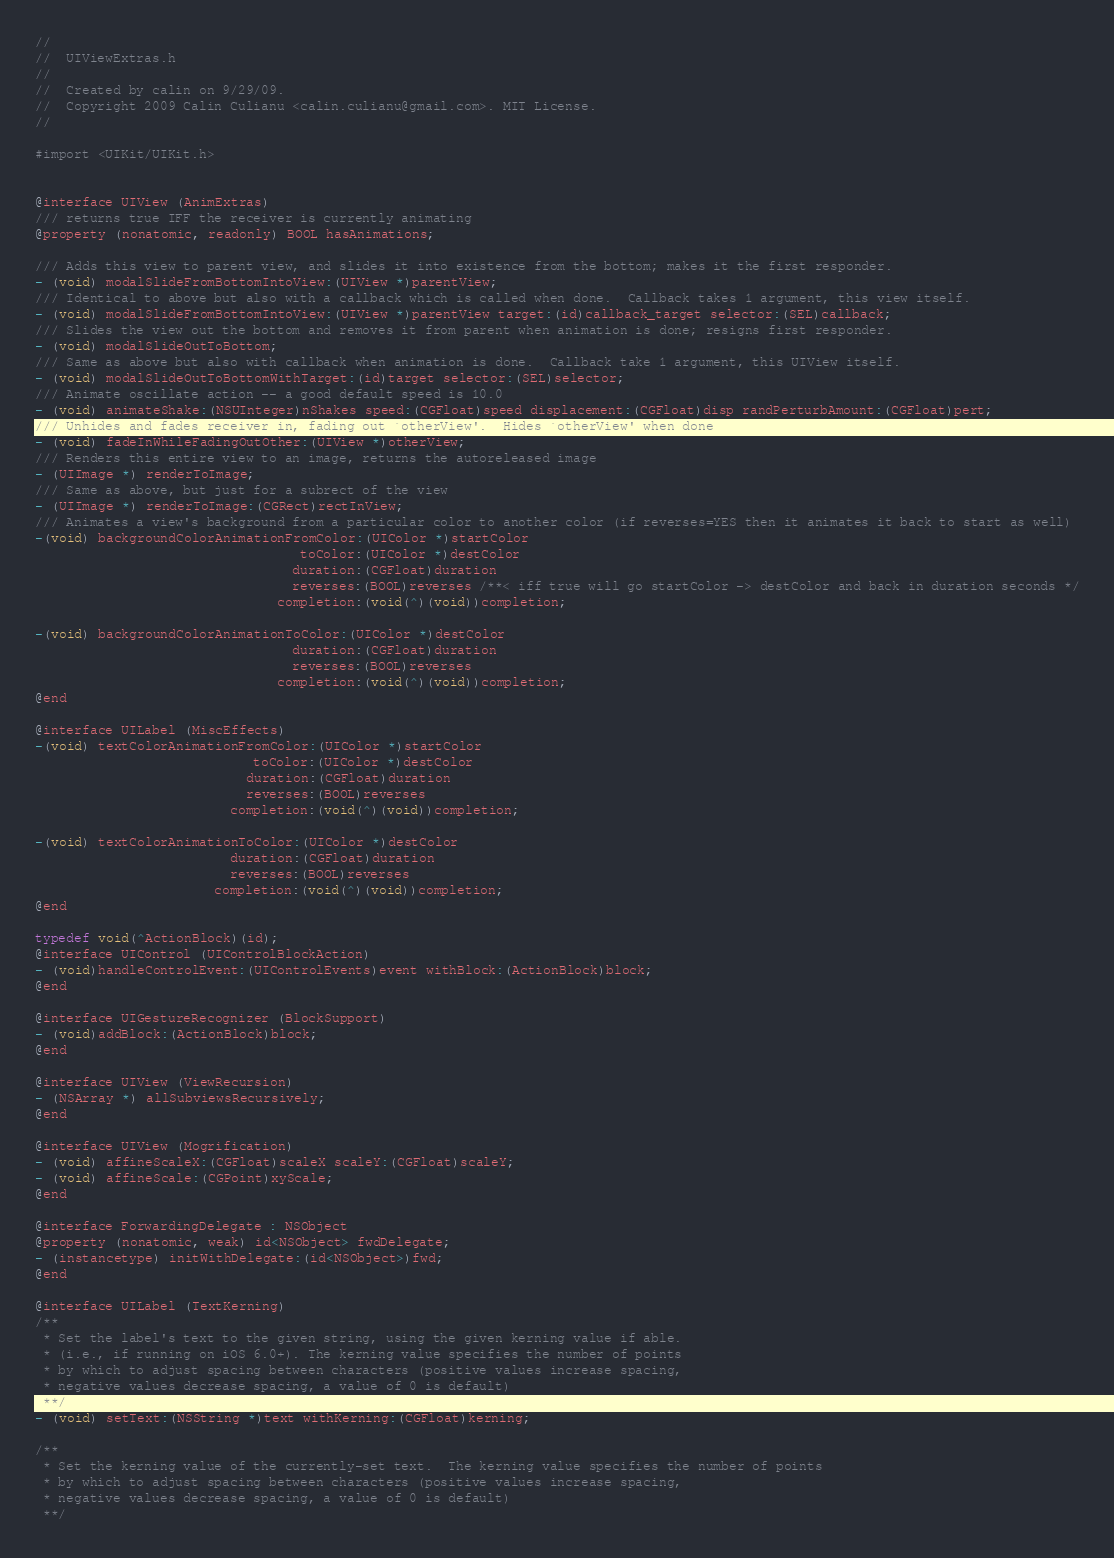<code> <loc_0><loc_0><loc_500><loc_500><_C_>//
//  UIViewExtras.h
//
//  Created by calin on 9/29/09.
//  Copyright 2009 Calin Culianu <calin.culianu@gmail.com>. MIT License.
//

#import <UIKit/UIKit.h>


@interface UIView (AnimExtras)
/// returns true IFF the receiver is currently animating
@property (nonatomic, readonly) BOOL hasAnimations;

/// Adds this view to parent view, and slides it into existence from the bottom; makes it the first responder.
- (void) modalSlideFromBottomIntoView:(UIView *)parentView;
/// Identical to above but also with a callback which is called when done.  Callback takes 1 argument, this view itself.
- (void) modalSlideFromBottomIntoView:(UIView *)parentView target:(id)callback_target selector:(SEL)callback;
/// Slides the view out the bottom and removes it from parent when animation is done; resigns first responder.
- (void) modalSlideOutToBottom;
/// Same as above but also with callback when animation is done.  Callback take 1 argument, this UIView itself.
- (void) modalSlideOutToBottomWithTarget:(id)target selector:(SEL)selector;
/// Animate oscillate action -- a good default speed is 10.0
- (void) animateShake:(NSUInteger)nShakes speed:(CGFloat)speed displacement:(CGFloat)disp randPerturbAmount:(CGFloat)pert;
/// Unhides and fades receiver in, fading out `otherView'.  Hides `otherView' when done
- (void) fadeInWhileFadingOutOther:(UIView *)otherView;
/// Renders this entire view to an image, returns the autoreleased image
- (UIImage *) renderToImage;
/// Same as above, but just for a subrect of the view
- (UIImage *) renderToImage:(CGRect)rectInView;
/// Animates a view's background from a particular color to another color (if reverses=YES then it animates it back to start as well)
-(void) backgroundColorAnimationFromColor:(UIColor *)startColor
                                  toColor:(UIColor *)destColor
                                 duration:(CGFloat)duration
                                 reverses:(BOOL)reverses /**< iff true will go startColor -> destColor and back in duration seconds */
                               completion:(void(^)(void))completion;

-(void) backgroundColorAnimationToColor:(UIColor *)destColor
                                 duration:(CGFloat)duration
                                 reverses:(BOOL)reverses
                               completion:(void(^)(void))completion;
@end

@interface UILabel (MiscEffects)
-(void) textColorAnimationFromColor:(UIColor *)startColor
                            toColor:(UIColor *)destColor
                           duration:(CGFloat)duration
                           reverses:(BOOL)reverses
                         completion:(void(^)(void))completion;

-(void) textColorAnimationToColor:(UIColor *)destColor
                         duration:(CGFloat)duration
                         reverses:(BOOL)reverses
                       completion:(void(^)(void))completion;
@end

typedef void(^ActionBlock)(id);
@interface UIControl (UIControlBlockAction)
- (void)handleControlEvent:(UIControlEvents)event withBlock:(ActionBlock)block;
@end

@interface UIGestureRecognizer (BlockSupport)
- (void)addBlock:(ActionBlock)block;
@end

@interface UIView (ViewRecursion)
- (NSArray *) allSubviewsRecursively;
@end

@interface UIView (Mogrification)
- (void) affineScaleX:(CGFloat)scaleX scaleY:(CGFloat)scaleY;
- (void) affineScale:(CGPoint)xyScale;
@end

@interface ForwardingDelegate : NSObject
@property (nonatomic, weak) id<NSObject> fwdDelegate;
- (instancetype) initWithDelegate:(id<NSObject>)fwd;
@end

@interface UILabel (TextKerning)
/**
 * Set the label's text to the given string, using the given kerning value if able.
 * (i.e., if running on iOS 6.0+). The kerning value specifies the number of points
 * by which to adjust spacing between characters (positive values increase spacing,
 * negative values decrease spacing, a value of 0 is default)
 **/
- (void) setText:(NSString *)text withKerning:(CGFloat)kerning;

/**
 * Set the kerning value of the currently-set text.  The kerning value specifies the number of points
 * by which to adjust spacing between characters (positive values increase spacing,
 * negative values decrease spacing, a value of 0 is default)
 **/</code> 